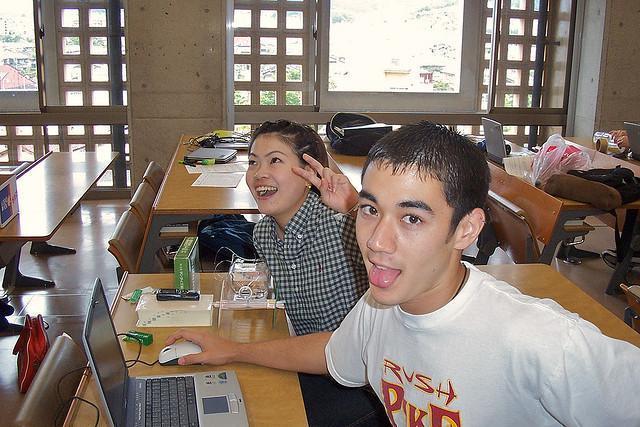How many people are in the picture?
Give a very brief answer. 2. How many backpacks are there?
Give a very brief answer. 2. How many chairs are there?
Give a very brief answer. 2. How many bears are there?
Give a very brief answer. 0. 